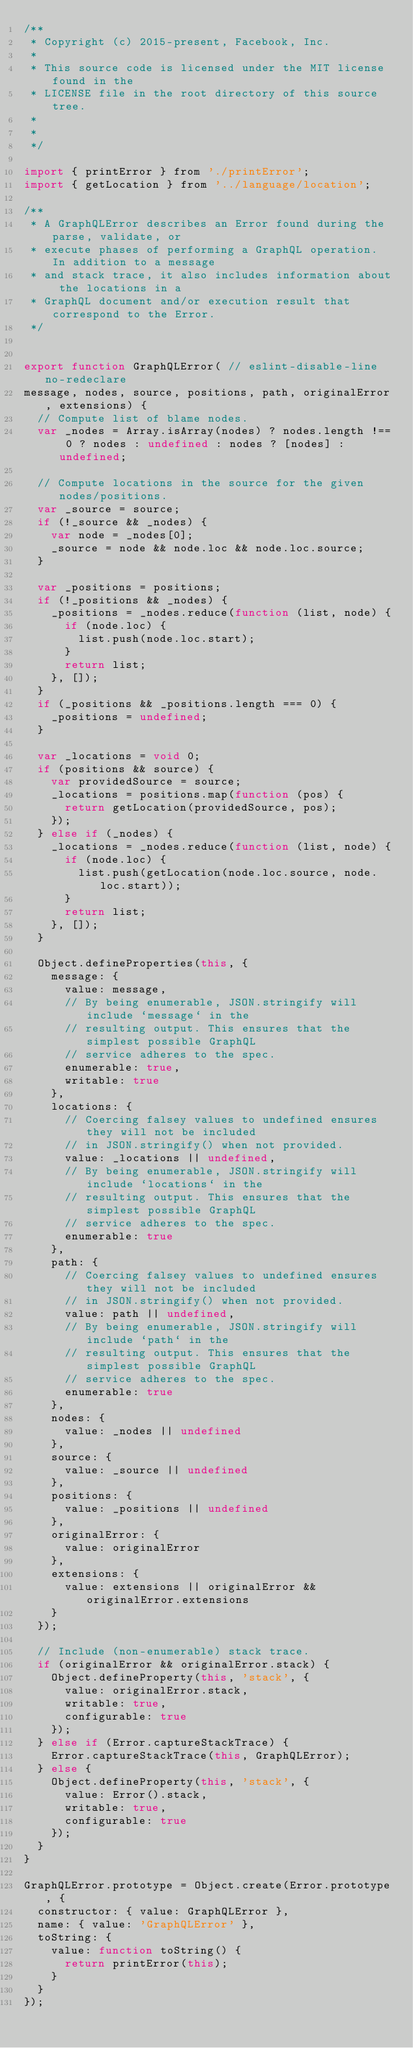<code> <loc_0><loc_0><loc_500><loc_500><_JavaScript_>/**
 * Copyright (c) 2015-present, Facebook, Inc.
 *
 * This source code is licensed under the MIT license found in the
 * LICENSE file in the root directory of this source tree.
 *
 * 
 */

import { printError } from './printError';
import { getLocation } from '../language/location';

/**
 * A GraphQLError describes an Error found during the parse, validate, or
 * execute phases of performing a GraphQL operation. In addition to a message
 * and stack trace, it also includes information about the locations in a
 * GraphQL document and/or execution result that correspond to the Error.
 */


export function GraphQLError( // eslint-disable-line no-redeclare
message, nodes, source, positions, path, originalError, extensions) {
  // Compute list of blame nodes.
  var _nodes = Array.isArray(nodes) ? nodes.length !== 0 ? nodes : undefined : nodes ? [nodes] : undefined;

  // Compute locations in the source for the given nodes/positions.
  var _source = source;
  if (!_source && _nodes) {
    var node = _nodes[0];
    _source = node && node.loc && node.loc.source;
  }

  var _positions = positions;
  if (!_positions && _nodes) {
    _positions = _nodes.reduce(function (list, node) {
      if (node.loc) {
        list.push(node.loc.start);
      }
      return list;
    }, []);
  }
  if (_positions && _positions.length === 0) {
    _positions = undefined;
  }

  var _locations = void 0;
  if (positions && source) {
    var providedSource = source;
    _locations = positions.map(function (pos) {
      return getLocation(providedSource, pos);
    });
  } else if (_nodes) {
    _locations = _nodes.reduce(function (list, node) {
      if (node.loc) {
        list.push(getLocation(node.loc.source, node.loc.start));
      }
      return list;
    }, []);
  }

  Object.defineProperties(this, {
    message: {
      value: message,
      // By being enumerable, JSON.stringify will include `message` in the
      // resulting output. This ensures that the simplest possible GraphQL
      // service adheres to the spec.
      enumerable: true,
      writable: true
    },
    locations: {
      // Coercing falsey values to undefined ensures they will not be included
      // in JSON.stringify() when not provided.
      value: _locations || undefined,
      // By being enumerable, JSON.stringify will include `locations` in the
      // resulting output. This ensures that the simplest possible GraphQL
      // service adheres to the spec.
      enumerable: true
    },
    path: {
      // Coercing falsey values to undefined ensures they will not be included
      // in JSON.stringify() when not provided.
      value: path || undefined,
      // By being enumerable, JSON.stringify will include `path` in the
      // resulting output. This ensures that the simplest possible GraphQL
      // service adheres to the spec.
      enumerable: true
    },
    nodes: {
      value: _nodes || undefined
    },
    source: {
      value: _source || undefined
    },
    positions: {
      value: _positions || undefined
    },
    originalError: {
      value: originalError
    },
    extensions: {
      value: extensions || originalError && originalError.extensions
    }
  });

  // Include (non-enumerable) stack trace.
  if (originalError && originalError.stack) {
    Object.defineProperty(this, 'stack', {
      value: originalError.stack,
      writable: true,
      configurable: true
    });
  } else if (Error.captureStackTrace) {
    Error.captureStackTrace(this, GraphQLError);
  } else {
    Object.defineProperty(this, 'stack', {
      value: Error().stack,
      writable: true,
      configurable: true
    });
  }
}

GraphQLError.prototype = Object.create(Error.prototype, {
  constructor: { value: GraphQLError },
  name: { value: 'GraphQLError' },
  toString: {
    value: function toString() {
      return printError(this);
    }
  }
});</code> 